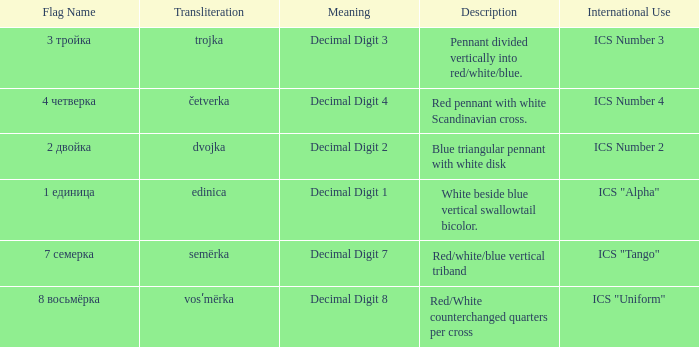What are the meanings of the flag whose name transliterates to semërka? Decimal Digit 7. 